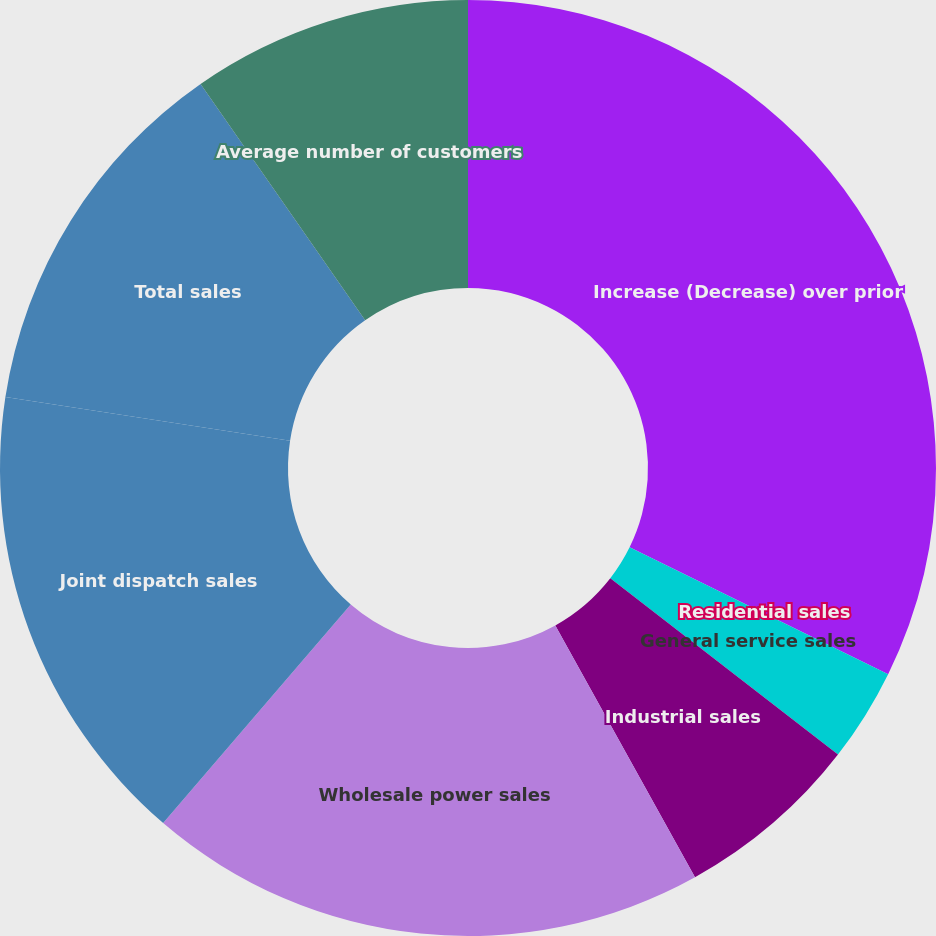Convert chart. <chart><loc_0><loc_0><loc_500><loc_500><pie_chart><fcel>Increase (Decrease) over prior<fcel>Residential sales<fcel>General service sales<fcel>Industrial sales<fcel>Wholesale power sales<fcel>Joint dispatch sales<fcel>Total sales<fcel>Average number of customers<nl><fcel>32.26%<fcel>0.0%<fcel>3.23%<fcel>6.45%<fcel>19.35%<fcel>16.13%<fcel>12.9%<fcel>9.68%<nl></chart> 